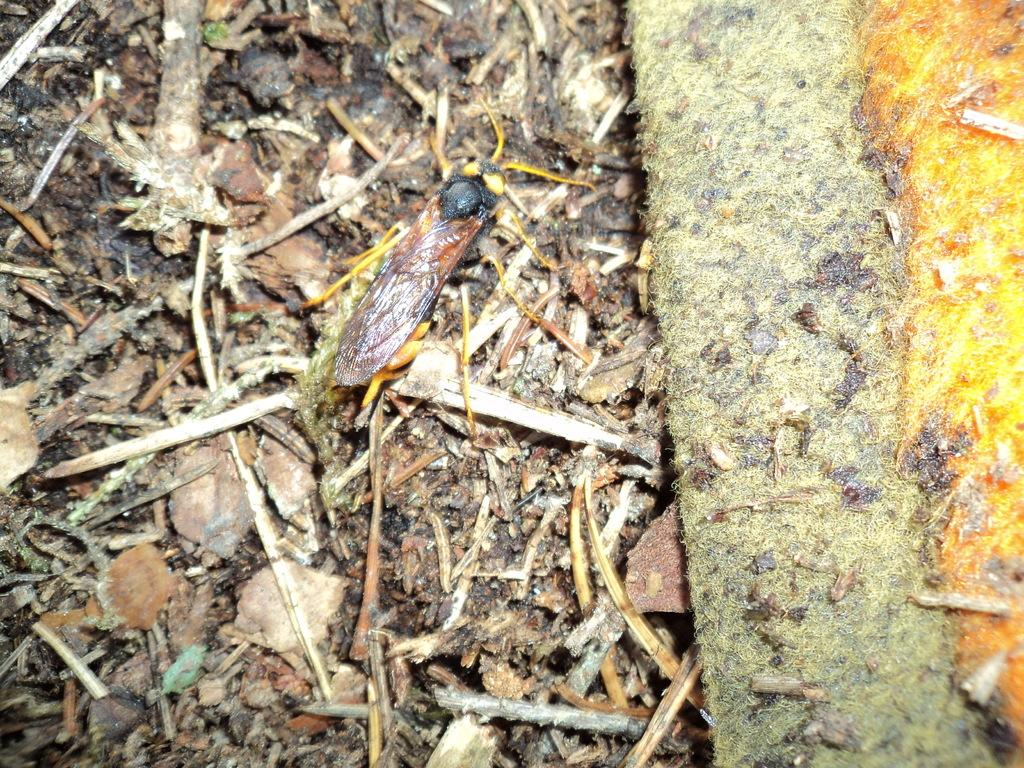What type of creature is in the image? There is an insect in the image. What colors can be seen on the insect? The insect has black and brown colors. Where is the insect located in the image? The insect is on the ground. What type of natural elements can be seen in the image? There are dried leaves and sticks in the image. What type of sidewalk can be seen in the image? There is no sidewalk present in the image. What selection of items is available for purchase in the image? The image does not depict any items for purchase. 